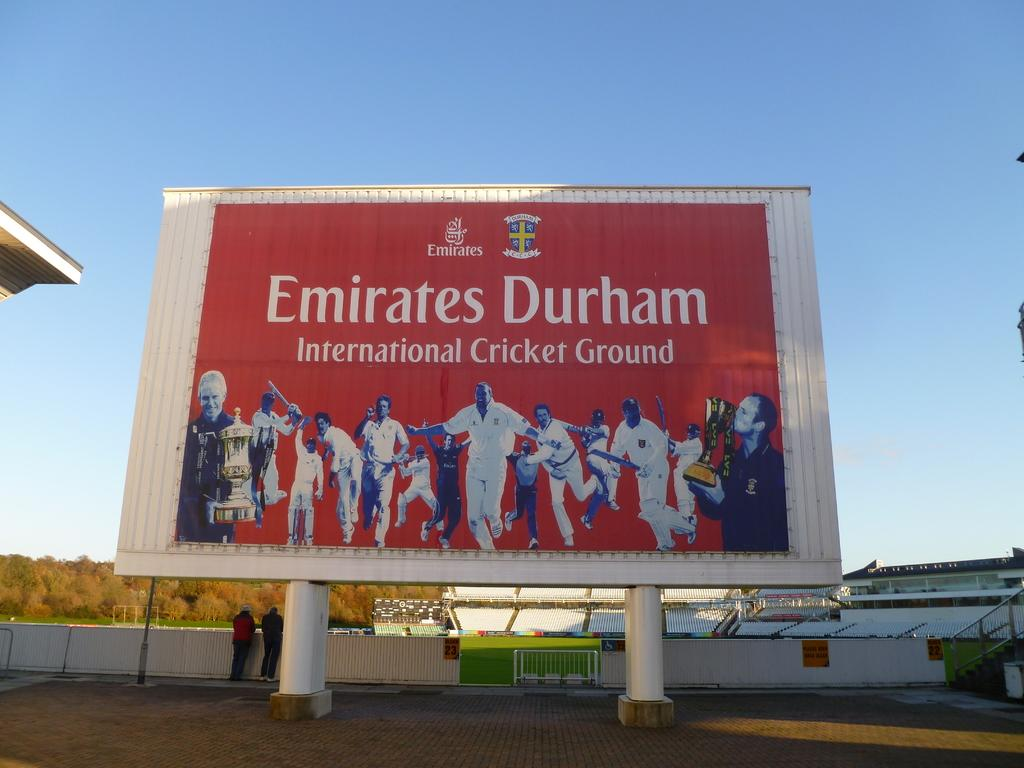<image>
Write a terse but informative summary of the picture. A large red sign showing a baseball team and says Emirates Durham in white letters. 